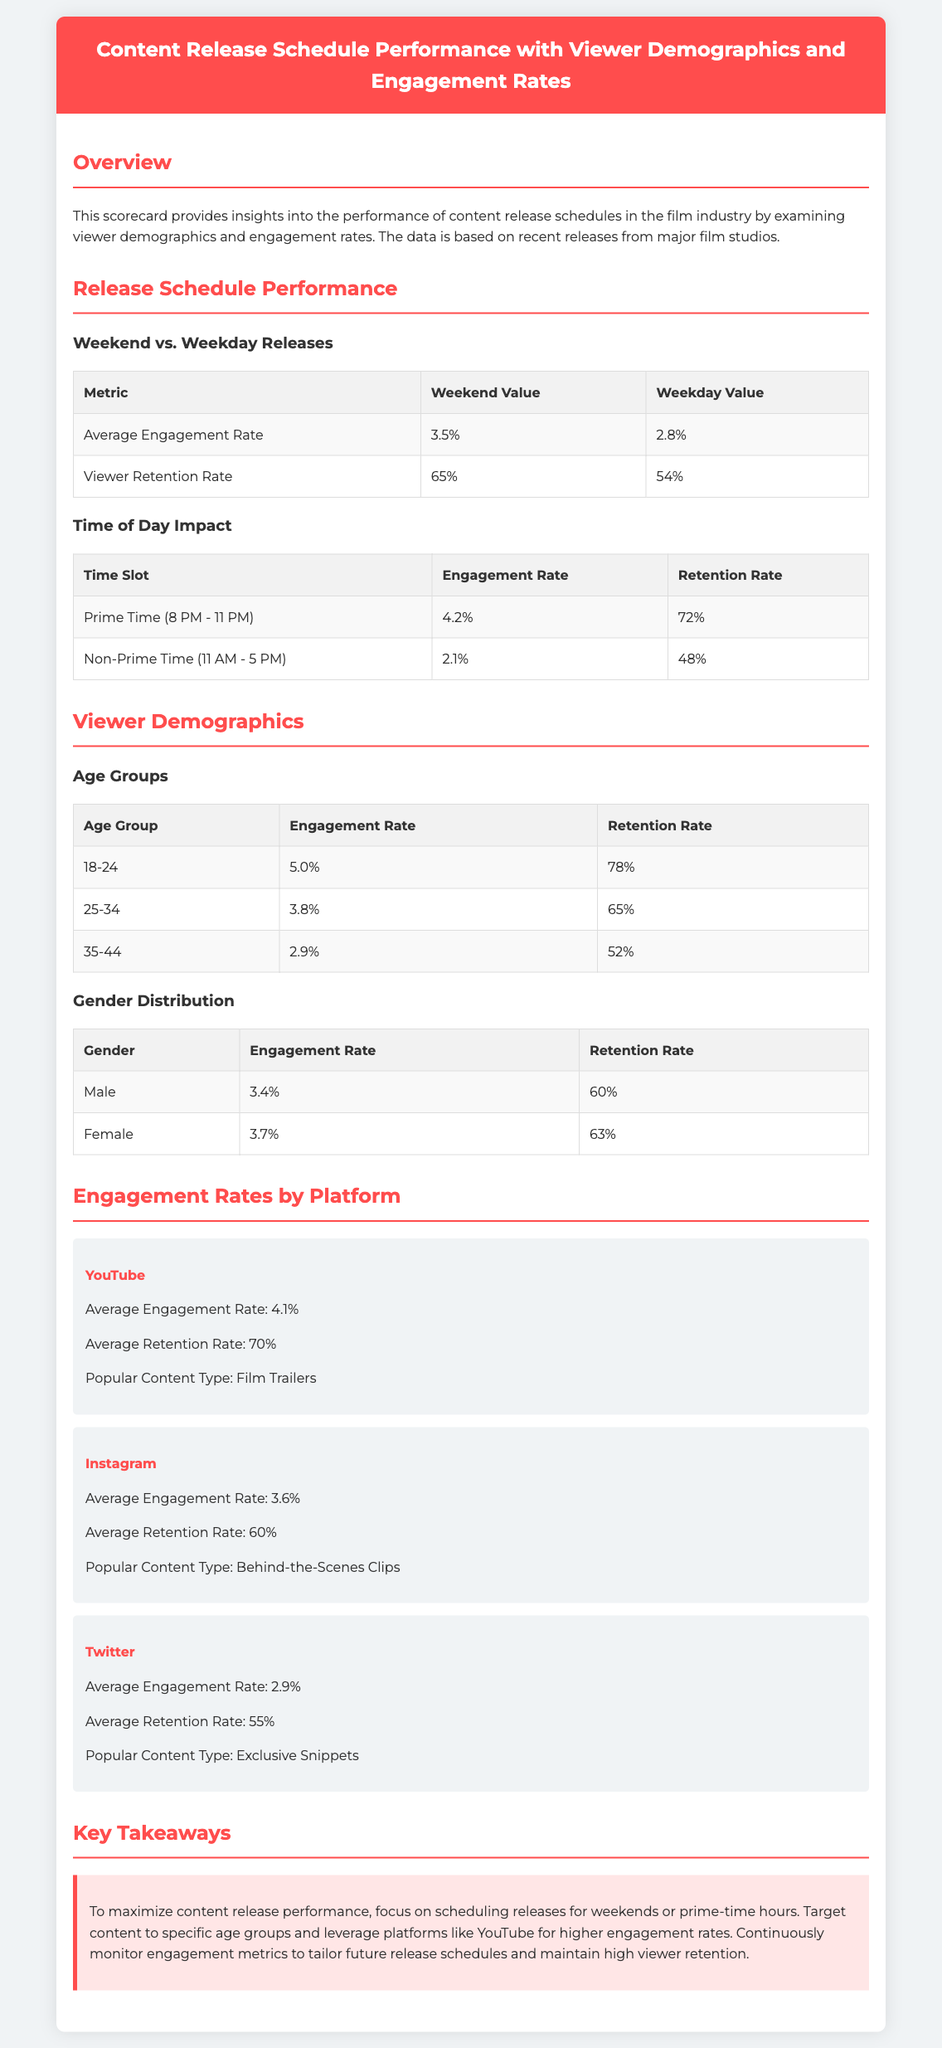What is the average engagement rate for weekday releases? The average engagement rate for weekday releases is specified as 2.8%.
Answer: 2.8% Which age group has the highest retention rate? The age group with the highest retention rate is the 18-24 age group, which retains 78%.
Answer: 18-24 What is the average engagement rate on YouTube? The average engagement rate on YouTube is listed as 4.1%.
Answer: 4.1% Which gender has a higher engagement rate? The engagement rates show that Female has a higher engagement rate at 3.7% compared to Male's 3.4%.
Answer: Female What time slot has the highest retention rate? The time slot with the highest retention rate is Prime Time, which has a retention rate of 72%.
Answer: Prime Time According to the scorecard, what is a recommended time to release content? The scorecard recommends scheduling releases for weekends or prime-time hours for better performance.
Answer: Weekends or prime-time hours What is the average retention rate for 25-34 age group? The average retention rate for the 25-34 age group is recorded as 65%.
Answer: 65% Which platform has the lowest engagement rate? The platform with the lowest engagement rate is Twitter, which has an engagement rate of 2.9%.
Answer: Twitter 